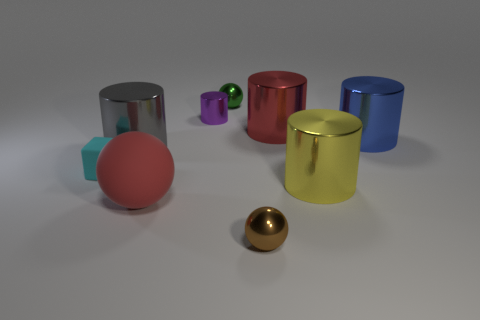Does the big matte object have the same color as the large thing behind the big blue cylinder?
Your response must be concise. Yes. How many red spheres are the same size as the yellow cylinder?
Keep it short and to the point. 1. There is a red shiny object; what number of big objects are left of it?
Ensure brevity in your answer.  2. The big red thing right of the sphere in front of the large matte sphere is made of what material?
Offer a very short reply. Metal. Are there any shiny things of the same color as the big sphere?
Your response must be concise. Yes. There is a red object that is the same material as the tiny green thing; what size is it?
Your answer should be compact. Large. Are there any other things of the same color as the big rubber thing?
Keep it short and to the point. Yes. What color is the tiny sphere in front of the red shiny cylinder?
Your response must be concise. Brown. Is there a rubber thing that is in front of the small sphere that is on the right side of the small ball that is behind the gray cylinder?
Ensure brevity in your answer.  No. Are there more small brown spheres right of the small brown ball than green spheres?
Offer a terse response. No. 